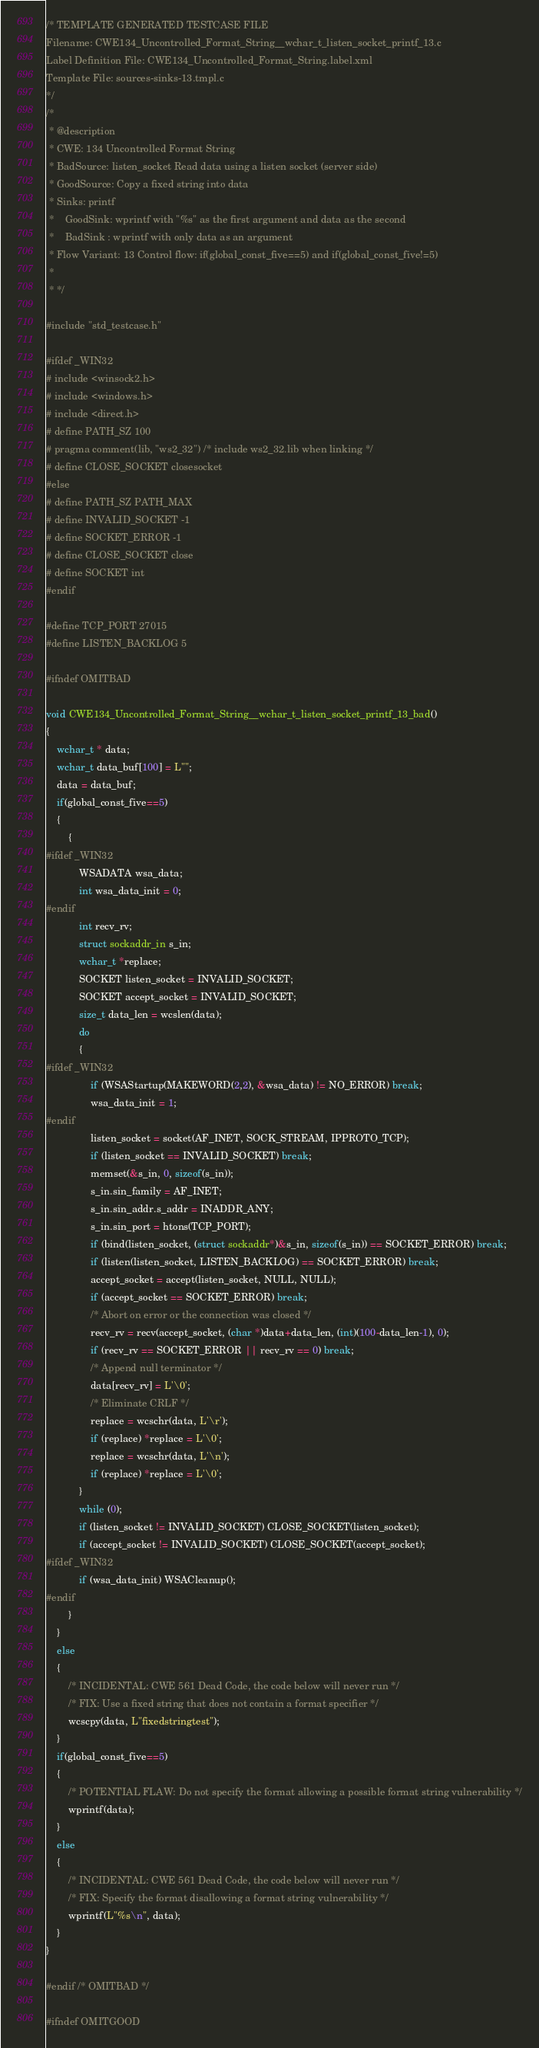<code> <loc_0><loc_0><loc_500><loc_500><_C_>/* TEMPLATE GENERATED TESTCASE FILE
Filename: CWE134_Uncontrolled_Format_String__wchar_t_listen_socket_printf_13.c
Label Definition File: CWE134_Uncontrolled_Format_String.label.xml
Template File: sources-sinks-13.tmpl.c
*/
/*
 * @description
 * CWE: 134 Uncontrolled Format String
 * BadSource: listen_socket Read data using a listen socket (server side)
 * GoodSource: Copy a fixed string into data
 * Sinks: printf
 *    GoodSink: wprintf with "%s" as the first argument and data as the second
 *    BadSink : wprintf with only data as an argument
 * Flow Variant: 13 Control flow: if(global_const_five==5) and if(global_const_five!=5)
 *
 * */

#include "std_testcase.h"

#ifdef _WIN32
# include <winsock2.h>
# include <windows.h>
# include <direct.h>
# define PATH_SZ 100
# pragma comment(lib, "ws2_32") /* include ws2_32.lib when linking */
# define CLOSE_SOCKET closesocket
#else
# define PATH_SZ PATH_MAX
# define INVALID_SOCKET -1
# define SOCKET_ERROR -1
# define CLOSE_SOCKET close
# define SOCKET int
#endif

#define TCP_PORT 27015
#define LISTEN_BACKLOG 5

#ifndef OMITBAD

void CWE134_Uncontrolled_Format_String__wchar_t_listen_socket_printf_13_bad()
{
    wchar_t * data;
    wchar_t data_buf[100] = L"";
    data = data_buf;
    if(global_const_five==5)
    {
        {
#ifdef _WIN32
            WSADATA wsa_data;
            int wsa_data_init = 0;
#endif
            int recv_rv;
            struct sockaddr_in s_in;
            wchar_t *replace;
            SOCKET listen_socket = INVALID_SOCKET;
            SOCKET accept_socket = INVALID_SOCKET;
            size_t data_len = wcslen(data);
            do
            {
#ifdef _WIN32
                if (WSAStartup(MAKEWORD(2,2), &wsa_data) != NO_ERROR) break;
                wsa_data_init = 1;
#endif
                listen_socket = socket(AF_INET, SOCK_STREAM, IPPROTO_TCP);
                if (listen_socket == INVALID_SOCKET) break;
                memset(&s_in, 0, sizeof(s_in));
                s_in.sin_family = AF_INET;
                s_in.sin_addr.s_addr = INADDR_ANY;
                s_in.sin_port = htons(TCP_PORT);
                if (bind(listen_socket, (struct sockaddr*)&s_in, sizeof(s_in)) == SOCKET_ERROR) break;
                if (listen(listen_socket, LISTEN_BACKLOG) == SOCKET_ERROR) break;
                accept_socket = accept(listen_socket, NULL, NULL);
                if (accept_socket == SOCKET_ERROR) break;
                /* Abort on error or the connection was closed */
                recv_rv = recv(accept_socket, (char *)data+data_len, (int)(100-data_len-1), 0);
                if (recv_rv == SOCKET_ERROR || recv_rv == 0) break;
                /* Append null terminator */
                data[recv_rv] = L'\0';
                /* Eliminate CRLF */
                replace = wcschr(data, L'\r');
                if (replace) *replace = L'\0';
                replace = wcschr(data, L'\n');
                if (replace) *replace = L'\0';
            }
            while (0);
            if (listen_socket != INVALID_SOCKET) CLOSE_SOCKET(listen_socket);
            if (accept_socket != INVALID_SOCKET) CLOSE_SOCKET(accept_socket);
#ifdef _WIN32
            if (wsa_data_init) WSACleanup();
#endif
        }
    }
    else
    {
        /* INCIDENTAL: CWE 561 Dead Code, the code below will never run */
        /* FIX: Use a fixed string that does not contain a format specifier */
        wcscpy(data, L"fixedstringtest");
    }
    if(global_const_five==5)
    {
        /* POTENTIAL FLAW: Do not specify the format allowing a possible format string vulnerability */
        wprintf(data);
    }
    else
    {
        /* INCIDENTAL: CWE 561 Dead Code, the code below will never run */
        /* FIX: Specify the format disallowing a format string vulnerability */
        wprintf(L"%s\n", data);
    }
}

#endif /* OMITBAD */

#ifndef OMITGOOD
</code> 